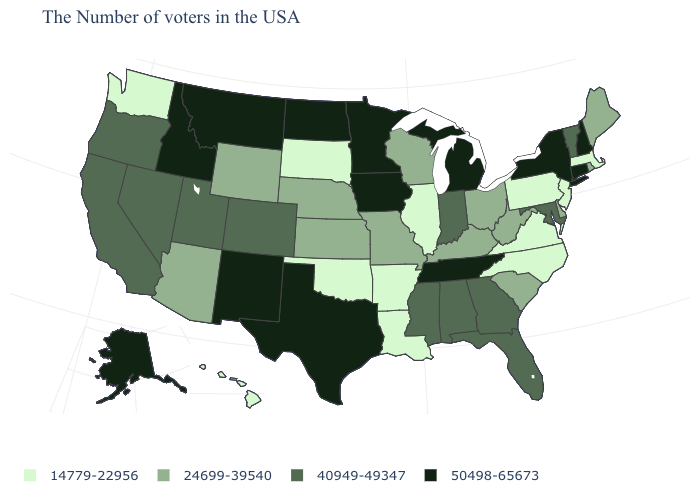What is the value of Texas?
Keep it brief. 50498-65673. Among the states that border West Virginia , which have the highest value?
Write a very short answer. Maryland. Name the states that have a value in the range 50498-65673?
Quick response, please. New Hampshire, Connecticut, New York, Michigan, Tennessee, Minnesota, Iowa, Texas, North Dakota, New Mexico, Montana, Idaho, Alaska. What is the value of Maryland?
Keep it brief. 40949-49347. Among the states that border Delaware , which have the highest value?
Keep it brief. Maryland. What is the lowest value in the USA?
Write a very short answer. 14779-22956. What is the value of Louisiana?
Quick response, please. 14779-22956. What is the value of New York?
Be succinct. 50498-65673. What is the lowest value in states that border Nevada?
Answer briefly. 24699-39540. What is the value of Nebraska?
Write a very short answer. 24699-39540. What is the lowest value in the MidWest?
Answer briefly. 14779-22956. Among the states that border North Carolina , which have the lowest value?
Write a very short answer. Virginia. Does the first symbol in the legend represent the smallest category?
Keep it brief. Yes. What is the value of Oklahoma?
Quick response, please. 14779-22956. What is the lowest value in the West?
Quick response, please. 14779-22956. 